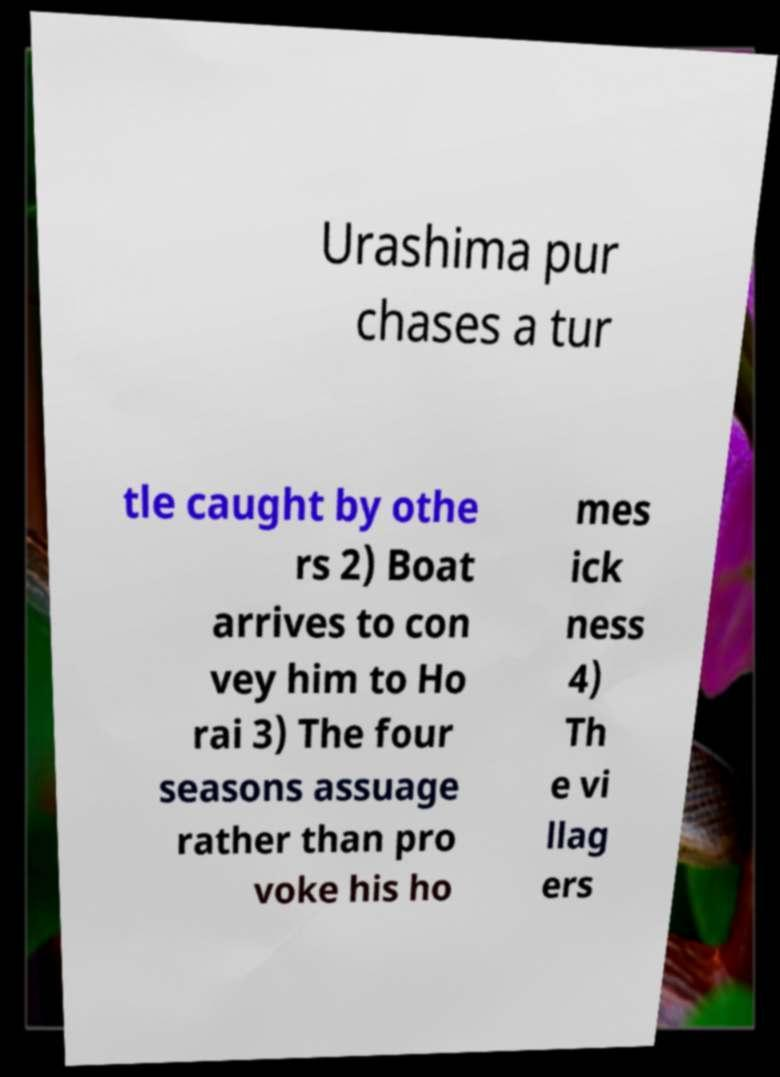There's text embedded in this image that I need extracted. Can you transcribe it verbatim? Urashima pur chases a tur tle caught by othe rs 2) Boat arrives to con vey him to Ho rai 3) The four seasons assuage rather than pro voke his ho mes ick ness 4) Th e vi llag ers 